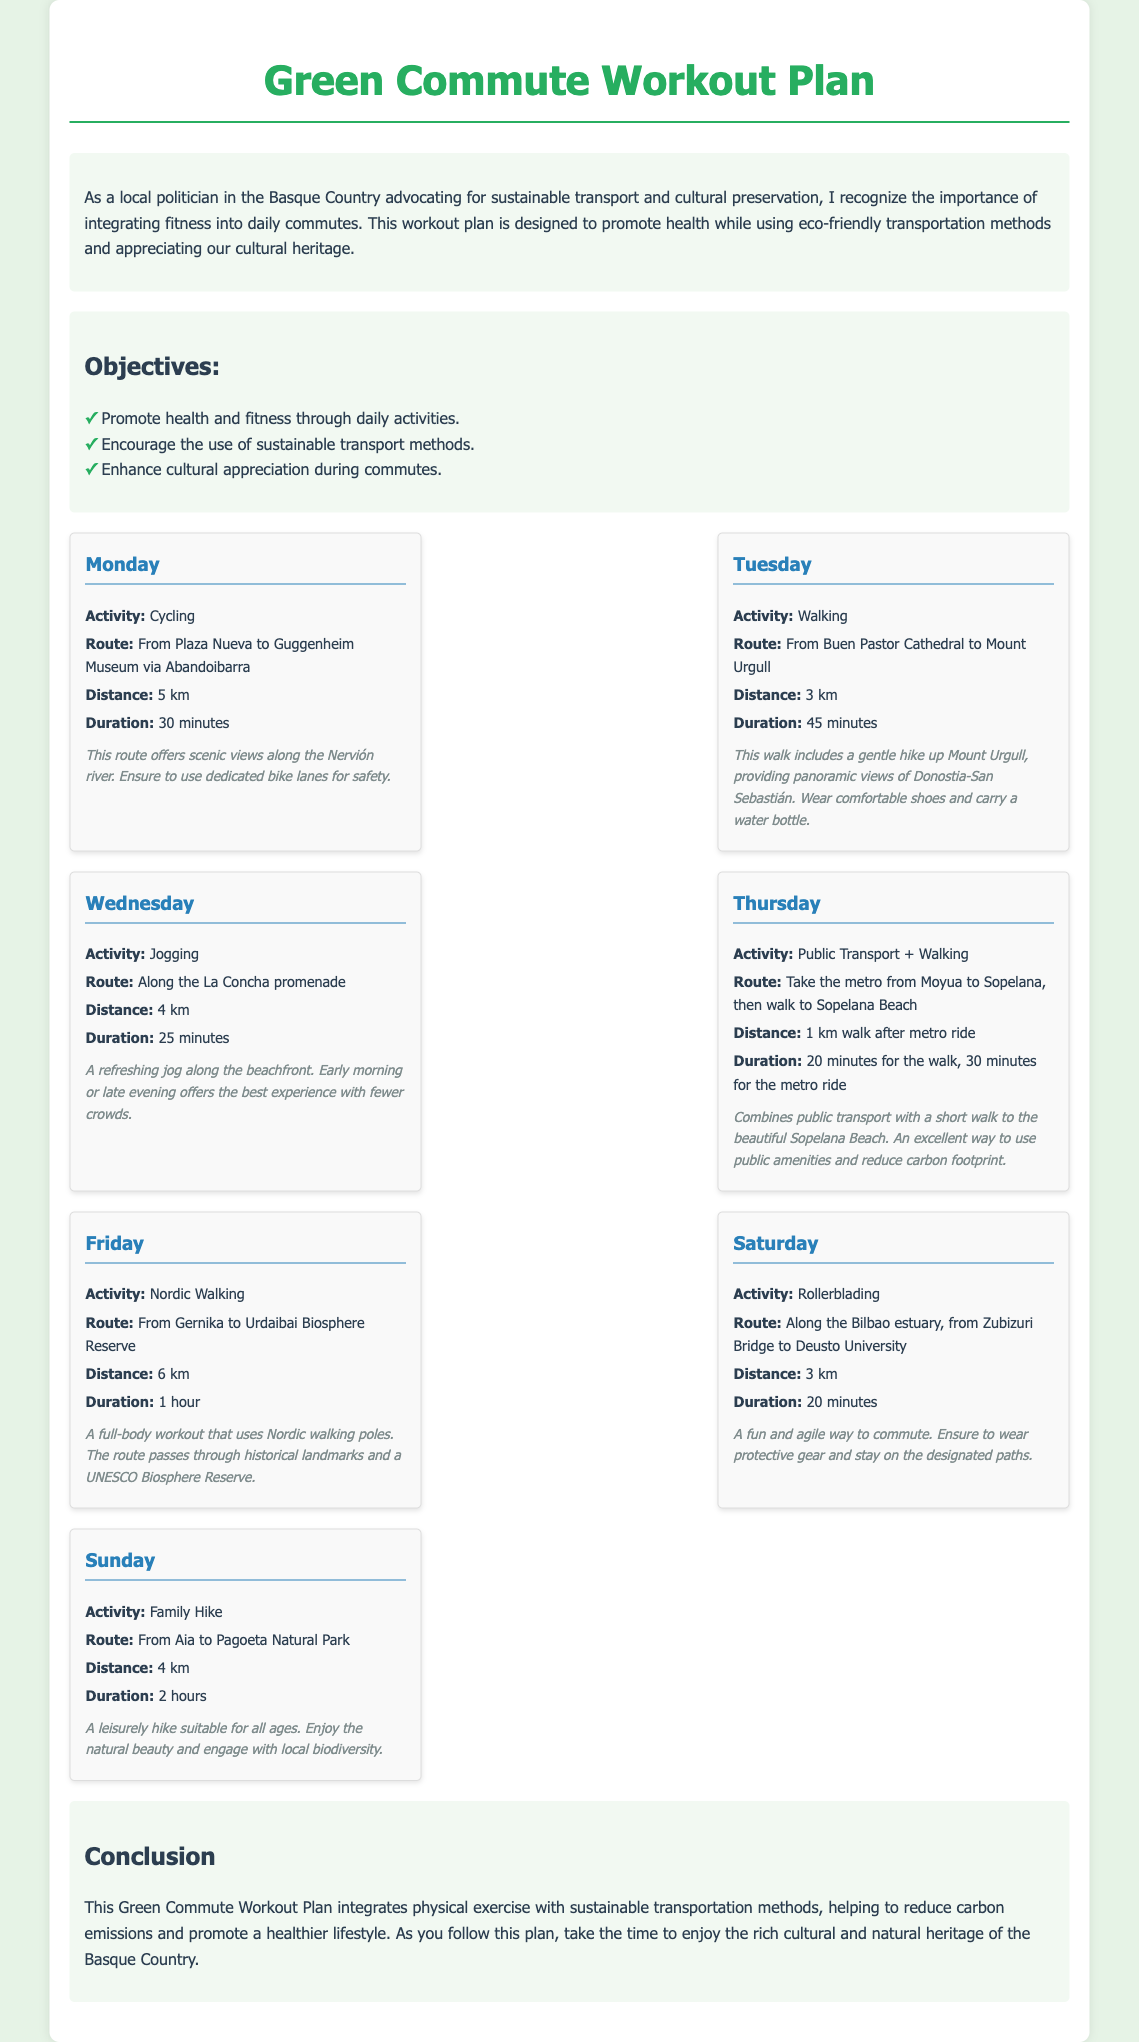What is the activity for Monday? The document lists cycling as the activity for Monday.
Answer: Cycling What is the distance for the Tuesday activity? The document states that the distance for Tuesday's activity (Walking) is 3 km.
Answer: 3 km What is the route for Friday's workout? The document specifies the route for Friday as "From Gernika to Urdaibai Biosphere Reserve."
Answer: From Gernika to Urdaibai Biosphere Reserve How long does the Nordic Walking session last? According to the document, the duration for the Nordic Walking session on Friday is 1 hour.
Answer: 1 hour How many kilometers will you cycle on Monday? The document indicates that the cycling route on Monday covers a distance of 5 km.
Answer: 5 km What transportation method is used on Thursday? The document mentions public transport as the method for Thursday's workout.
Answer: Public Transport What is the total distance for the Family Hike on Sunday? The document states that the Family Hike on Sunday covers a distance of 4 km.
Answer: 4 km Which day features a workout along the La Concha promenade? The document identifies Wednesday as the day for jogging along the La Concha promenade.
Answer: Wednesday What is a significant feature of the cycling route mentioned? The document notes that the cycling route offers scenic views along the Nervión river.
Answer: Scenic views along the Nervión river 